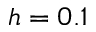Convert formula to latex. <formula><loc_0><loc_0><loc_500><loc_500>h = 0 . 1</formula> 